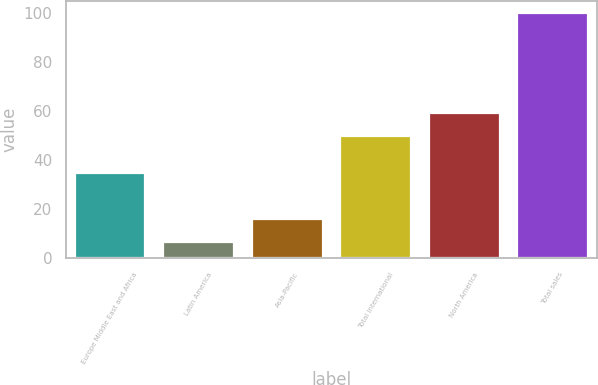Convert chart to OTSL. <chart><loc_0><loc_0><loc_500><loc_500><bar_chart><fcel>Europe Middle East and Africa<fcel>Latin America<fcel>Asia-Pacific<fcel>Total international<fcel>North America<fcel>Total sales<nl><fcel>34.8<fcel>6.6<fcel>15.94<fcel>50<fcel>59.34<fcel>100<nl></chart> 